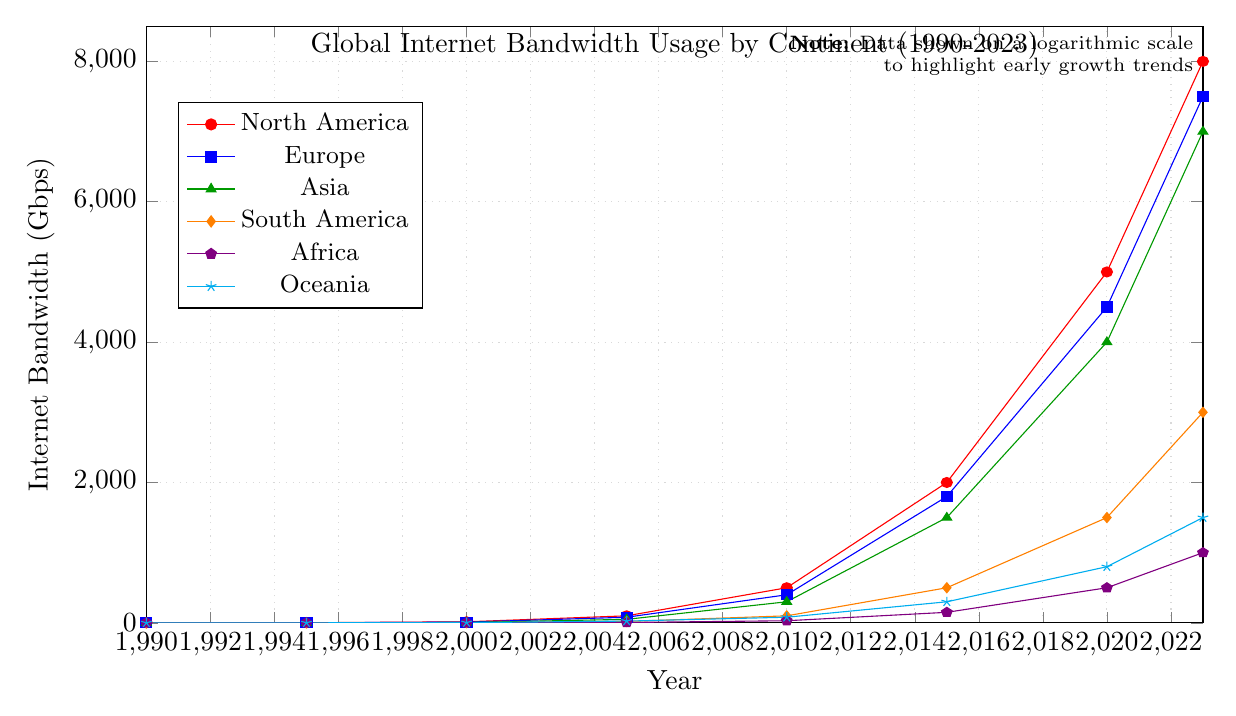What continent has the highest internet bandwidth usage in 2023? North America shows the highest internet bandwidth usage (8000 Gbps) in 2023. Refer to the line for North America, marked in red, to identify this.
Answer: North America How does the internet bandwidth usage in Asia in 2005 compare to Europe in the same year? In 2005, Asia's internet bandwidth usage is 50 Gbps, while Europe's is 80 Gbps. Compare the green line for Asia and the blue line for Europe at the year 2005.
Answer: Europe is higher What is the combined internet bandwidth usage of South America and Africa in 2020? In 2020, South America has 1500 Gbps and Africa has 500 Gbps. Adding these, 1500 + 500 = 2000 Gbps. Refer to the orange line for South America and the violet line for Africa in 2020.
Answer: 2000 Gbps Which continent had the most rapid increase in internet bandwidth usage between 1990 and 2023? Evaluate the slope of each line from 1990 to 2023. North America increases from 0.1 to 8000 Gbps, Europe from 0.05 to 7500 Gbps, etc. North America's slope is the steepest, indicating the most rapid increase.
Answer: North America What year did North America surpass 1000 Gbps in internet bandwidth usage? Follow the red line for North America and observe the value. The red line surpasses 1000 Gbps between 2005 (100 Gbps) to 2010 (500 Gbps).
Answer: Between 2005 and 2010 What is the difference in internet bandwidth usage between Oceania and Africa in 2023? In 2023, Oceania's bandwidth is 1500 Gbps, and Africa's is 1000 Gbps. Subtracting these values, 1500 - 1000 = 500 Gbps. Refer to the cyan line for Oceania and the violet line for Africa.
Answer: 500 Gbps Which continent had the lowest internet bandwidth usage in 2000? Check the values for each continent in 2000. Africa has 0.5 Gbps, the lowest compared to other continents.
Answer: Africa How has the internet bandwidth usage trend changed for South America from 1990 to 2023? Observe the orange line for South America. From 1990 (0.01 Gbps) to 2023 (3000 Gbps), the line shows a steady increase, indicating continuous growth in bandwidth usage.
Answer: Steady increase What is the average internet bandwidth usage in Europe from 2000 to 2020? Summing up the values for Europe: 10 + 80 + 400 + 1800 + 4500 = 7790 Gbps. There are 5 values, so the average is 7790/5 = 1558 Gbps.
Answer: 1558 Gbps Compare the growth trends between Asia and Oceania from 2010 to 2023. From 2010 to 2023, Asia increases from 300 to 7000 Gbps (6700 Gbps increase), while Oceania rises from 80 to 1500 Gbps (1420 Gbps increase). Asia's growth is much steeper than Oceania's, indicated by the slope of the green line compared to the cyan line.
Answer: Asia has a steeper increase 